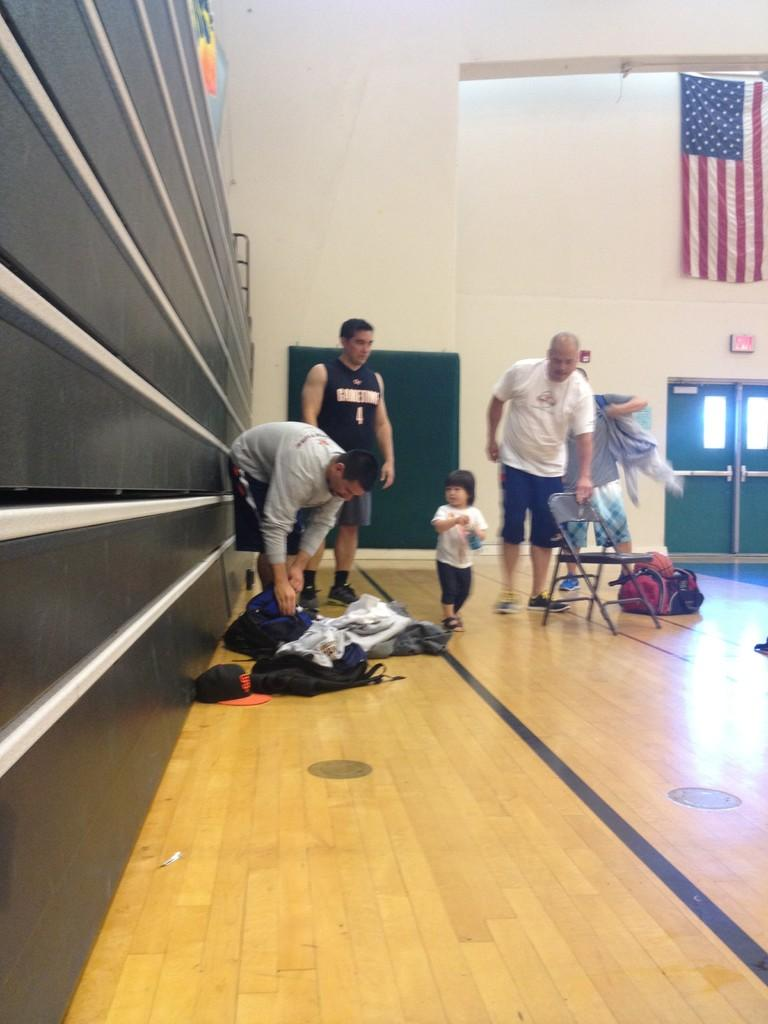What is happening in the image involving people? There are people standing in the image. What type of furniture is present in the image? There is a chair in the image. What objects can be seen in the image that might be used for carrying items? There are bags in the image. What is on the floor in the image? There are clothes on the floor in the image. What can be seen in the background of the image? There is a wall, a flag, and doors in the background of the image. What type of steam is coming out of the bags in the image? There is no steam coming out of the bags in the image; it is a factual error to assume that there is steam present. What kind of breakfast is being served on the chair in the image? There is no breakfast present in the image, and the chair is not associated with any food or meal. 